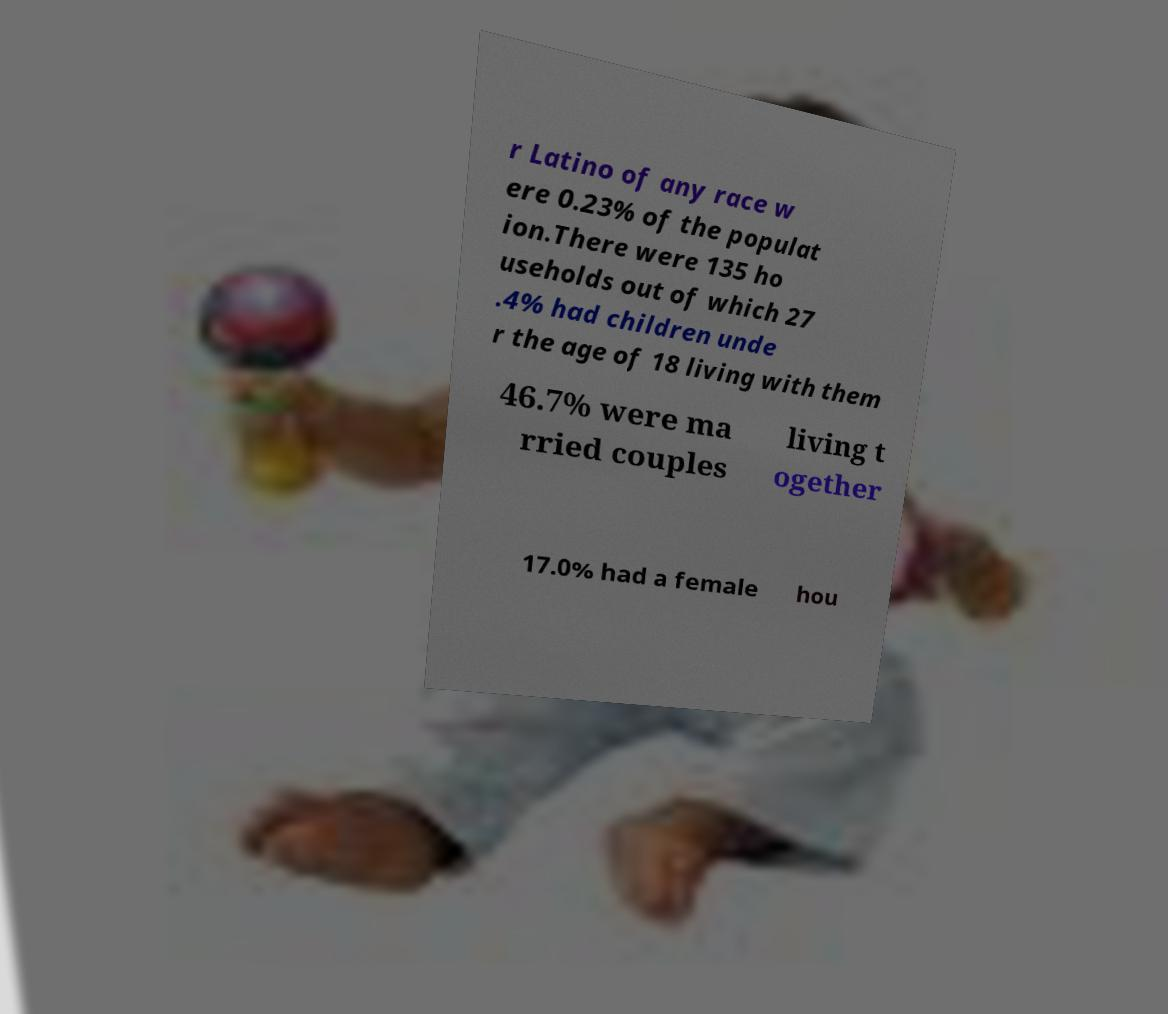For documentation purposes, I need the text within this image transcribed. Could you provide that? r Latino of any race w ere 0.23% of the populat ion.There were 135 ho useholds out of which 27 .4% had children unde r the age of 18 living with them 46.7% were ma rried couples living t ogether 17.0% had a female hou 